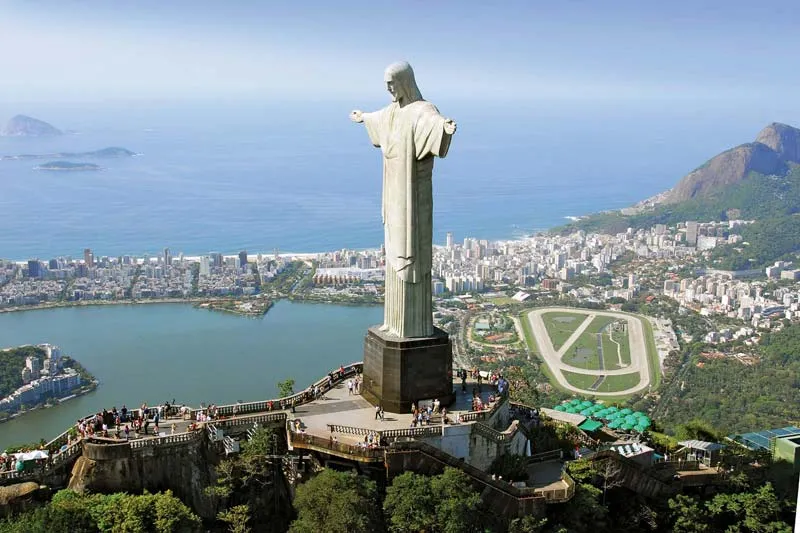Can you describe the main features of this image for me? The image presents the awe-inspiring Cristo Redentor, or Christ the Redeemer statue, a symbol of peace and faith, standing over Rio de Janeiro, Brazil. This art deco marvel of Jesus Christ has arms outstretched in an embrace, perched on a pedestal atop the Corcovado Mountain. Below, the urban sprawl of Rio intermingles with nature's splendor, housing amidst forested hills tumbling towards the glistening Atlantic Ocean. The foreground shows a bustling viewing platform, providing a sense of scale to the statue's monumental 30 meters. Warm sunlight illuminates the scene, while the cloudless sky above serves as a sublime backdrop, accentuating the harmonious blend of human artistry and natural grandeur. 